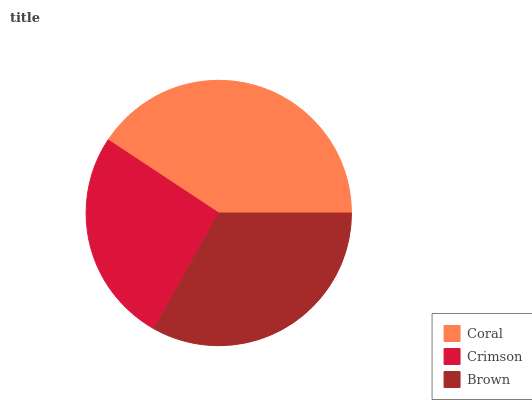Is Crimson the minimum?
Answer yes or no. Yes. Is Coral the maximum?
Answer yes or no. Yes. Is Brown the minimum?
Answer yes or no. No. Is Brown the maximum?
Answer yes or no. No. Is Brown greater than Crimson?
Answer yes or no. Yes. Is Crimson less than Brown?
Answer yes or no. Yes. Is Crimson greater than Brown?
Answer yes or no. No. Is Brown less than Crimson?
Answer yes or no. No. Is Brown the high median?
Answer yes or no. Yes. Is Brown the low median?
Answer yes or no. Yes. Is Coral the high median?
Answer yes or no. No. Is Coral the low median?
Answer yes or no. No. 